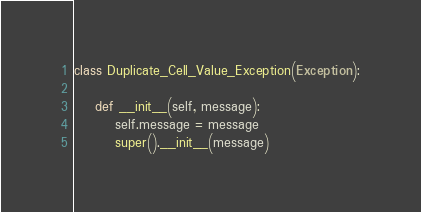Convert code to text. <code><loc_0><loc_0><loc_500><loc_500><_Python_>class Duplicate_Cell_Value_Exception(Exception):

    def __init__(self, message):
        self.message = message
        super().__init__(message)


</code> 